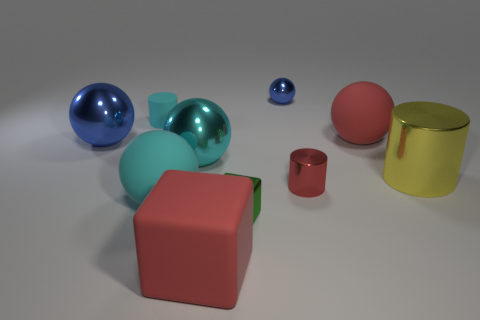How many things are either balls in front of the large blue ball or small blue spheres?
Your answer should be compact. 3. There is a blue ball that is left of the tiny cyan cylinder; how many rubber cylinders are in front of it?
Offer a very short reply. 0. Are there more small objects in front of the yellow metal cylinder than large gray metal cubes?
Give a very brief answer. Yes. There is a rubber thing that is right of the large cyan rubber thing and on the left side of the large red sphere; how big is it?
Your answer should be very brief. Large. There is a small object that is both right of the big cyan rubber ball and behind the big yellow metallic thing; what shape is it?
Provide a short and direct response. Sphere. There is a blue thing in front of the cylinder behind the big red sphere; is there a small blue object right of it?
Offer a very short reply. Yes. What number of objects are shiny cylinders in front of the large cylinder or tiny cylinders that are on the right side of the tiny green metallic object?
Offer a very short reply. 1. Does the blue ball that is behind the matte cylinder have the same material as the green cube?
Your answer should be compact. Yes. What is the small thing that is both behind the tiny red shiny object and in front of the small blue metal sphere made of?
Offer a very short reply. Rubber. There is a large matte sphere behind the large yellow thing that is in front of the matte cylinder; what is its color?
Your answer should be compact. Red. 